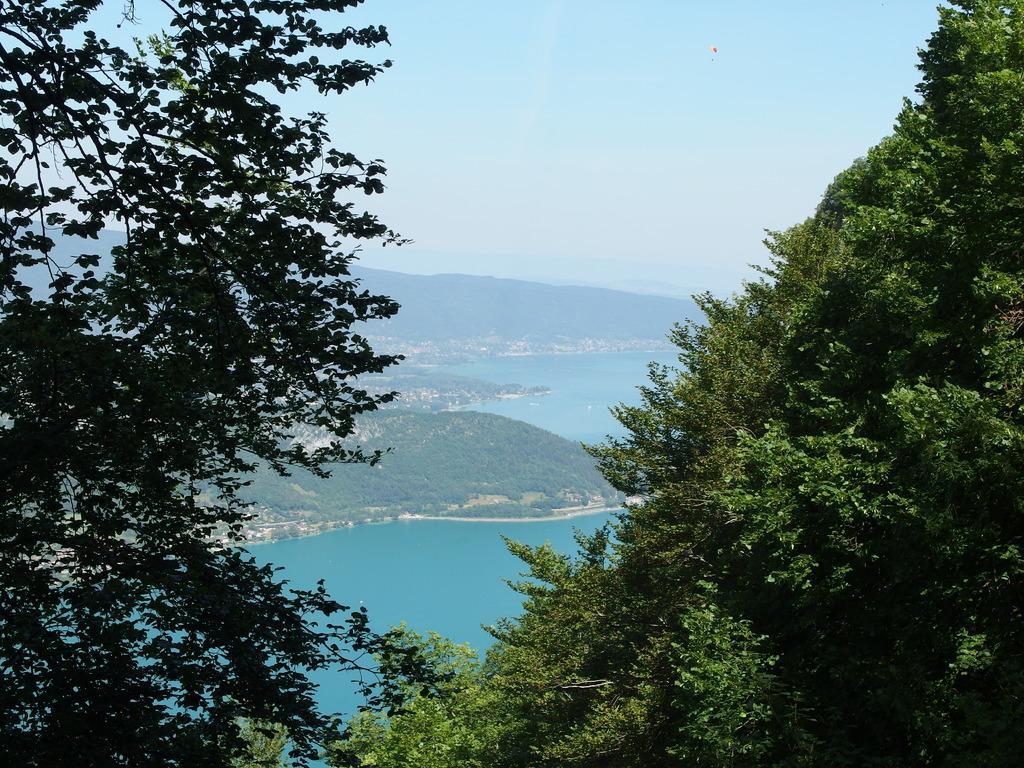Can you describe this image briefly? In the foreground of the picture there are trees. In the center of the picture there are hills covered with trees and there is a water body. At the top it is sky. 